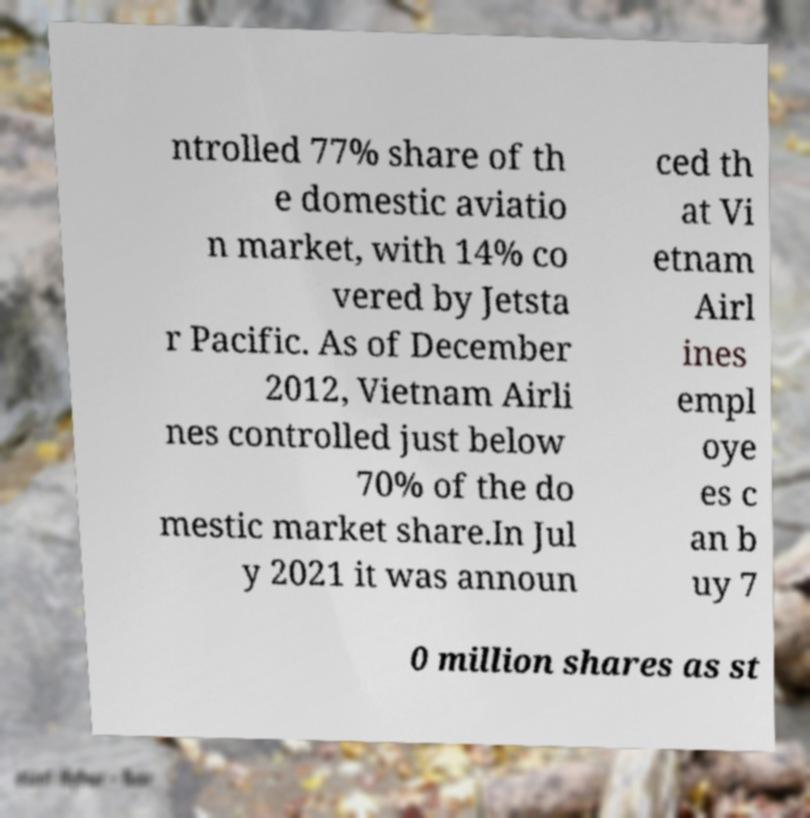What messages or text are displayed in this image? I need them in a readable, typed format. ntrolled 77% share of th e domestic aviatio n market, with 14% co vered by Jetsta r Pacific. As of December 2012, Vietnam Airli nes controlled just below 70% of the do mestic market share.In Jul y 2021 it was announ ced th at Vi etnam Airl ines empl oye es c an b uy 7 0 million shares as st 